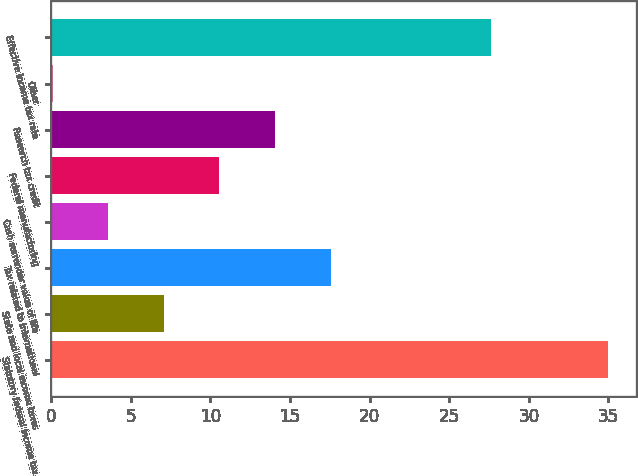Convert chart. <chart><loc_0><loc_0><loc_500><loc_500><bar_chart><fcel>Statutory federal income tax<fcel>State and local income taxes<fcel>Tax related to international<fcel>Cash surrender value of life<fcel>Federal manufacturing<fcel>Research tax credit<fcel>Other<fcel>Effective income tax rate<nl><fcel>35<fcel>7.08<fcel>17.55<fcel>3.59<fcel>10.57<fcel>14.06<fcel>0.1<fcel>27.6<nl></chart> 